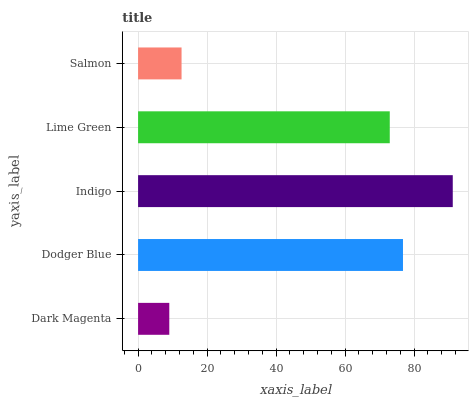Is Dark Magenta the minimum?
Answer yes or no. Yes. Is Indigo the maximum?
Answer yes or no. Yes. Is Dodger Blue the minimum?
Answer yes or no. No. Is Dodger Blue the maximum?
Answer yes or no. No. Is Dodger Blue greater than Dark Magenta?
Answer yes or no. Yes. Is Dark Magenta less than Dodger Blue?
Answer yes or no. Yes. Is Dark Magenta greater than Dodger Blue?
Answer yes or no. No. Is Dodger Blue less than Dark Magenta?
Answer yes or no. No. Is Lime Green the high median?
Answer yes or no. Yes. Is Lime Green the low median?
Answer yes or no. Yes. Is Indigo the high median?
Answer yes or no. No. Is Indigo the low median?
Answer yes or no. No. 